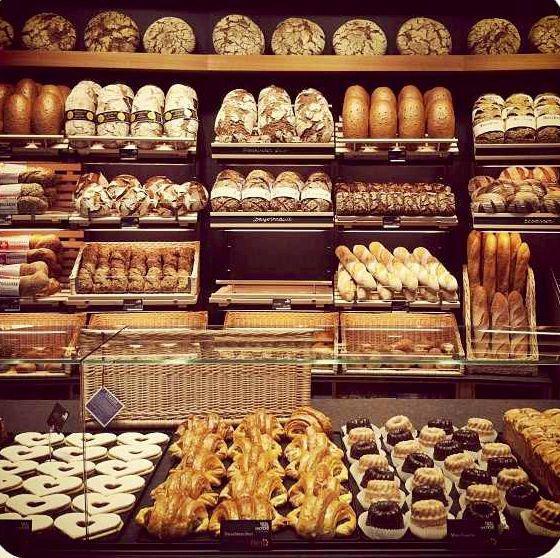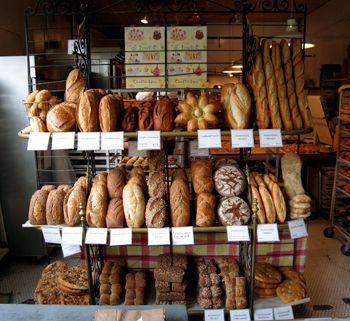The first image is the image on the left, the second image is the image on the right. For the images displayed, is the sentence "At least one image shows a uniformed bakery worker." factually correct? Answer yes or no. No. The first image is the image on the left, the second image is the image on the right. Given the left and right images, does the statement "In 1 of the images, a person is near bread." hold true? Answer yes or no. No. 